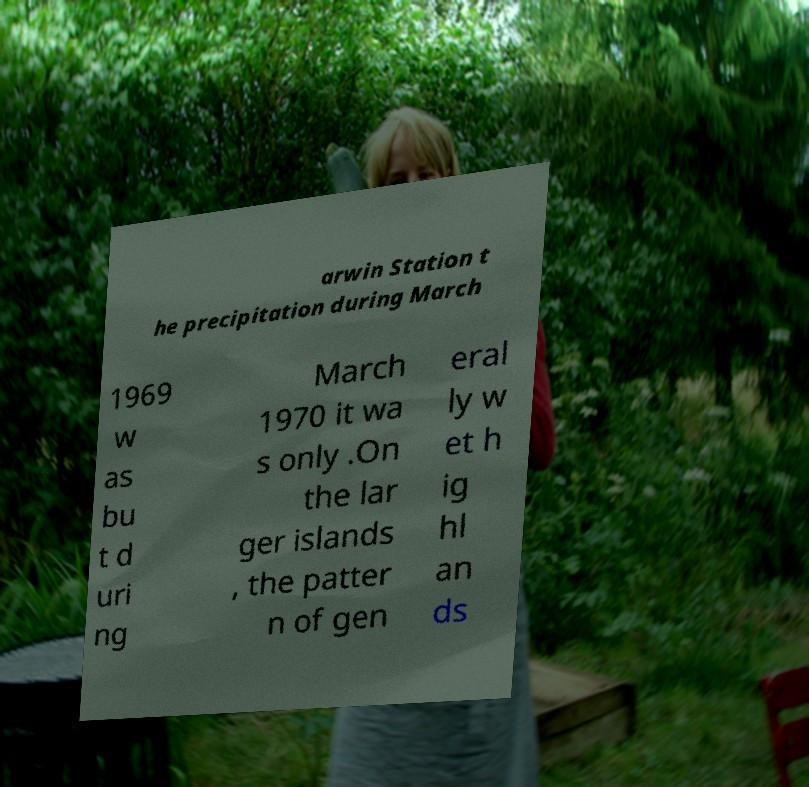Could you extract and type out the text from this image? arwin Station t he precipitation during March 1969 w as bu t d uri ng March 1970 it wa s only .On the lar ger islands , the patter n of gen eral ly w et h ig hl an ds 